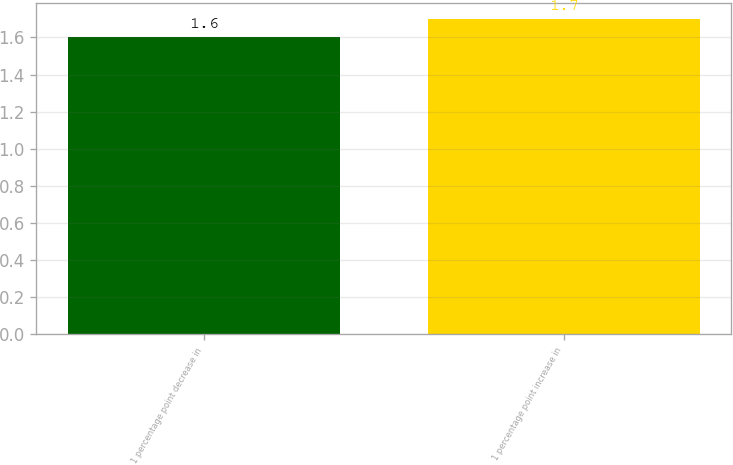<chart> <loc_0><loc_0><loc_500><loc_500><bar_chart><fcel>1 percentage point decrease in<fcel>1 percentage point increase in<nl><fcel>1.6<fcel>1.7<nl></chart> 